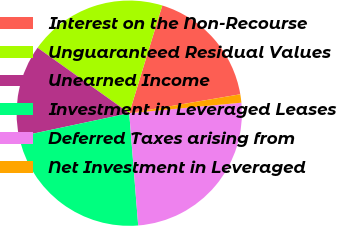Convert chart to OTSL. <chart><loc_0><loc_0><loc_500><loc_500><pie_chart><fcel>Interest on the Non-Recourse<fcel>Unguaranteed Residual Values<fcel>Unearned Income<fcel>Investment in Leveraged Leases<fcel>Deferred Taxes arising from<fcel>Net Investment in Leveraged<nl><fcel>17.58%<fcel>19.87%<fcel>13.2%<fcel>22.93%<fcel>25.22%<fcel>1.2%<nl></chart> 